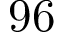<formula> <loc_0><loc_0><loc_500><loc_500>9 6</formula> 